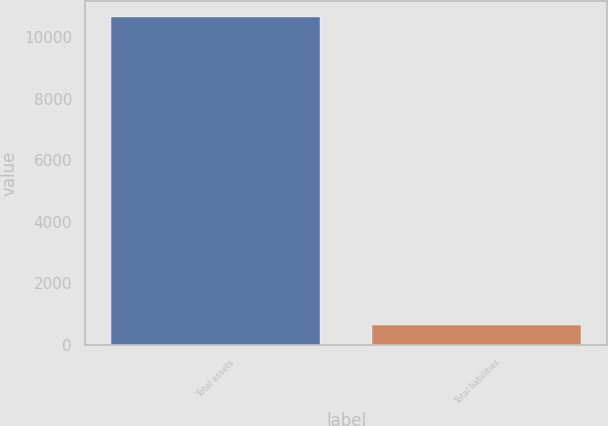Convert chart. <chart><loc_0><loc_0><loc_500><loc_500><bar_chart><fcel>Total assets<fcel>Total liabilities<nl><fcel>10650<fcel>638<nl></chart> 